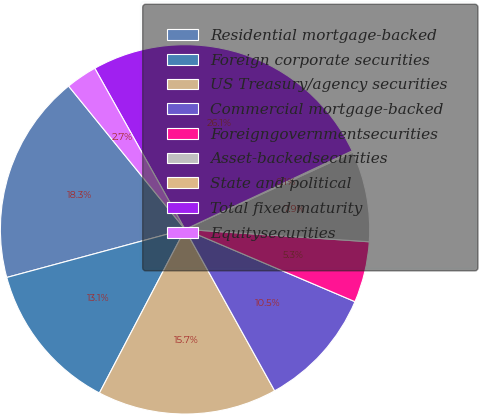Convert chart to OTSL. <chart><loc_0><loc_0><loc_500><loc_500><pie_chart><fcel>Residential mortgage-backed<fcel>Foreign corporate securities<fcel>US Treasury/agency securities<fcel>Commercial mortgage-backed<fcel>Foreigngovernmentsecurities<fcel>Asset-backedsecurities<fcel>State and political<fcel>Total fixed maturity<fcel>Equitysecurities<nl><fcel>18.33%<fcel>13.13%<fcel>15.73%<fcel>10.53%<fcel>5.33%<fcel>7.93%<fcel>0.13%<fcel>26.13%<fcel>2.73%<nl></chart> 